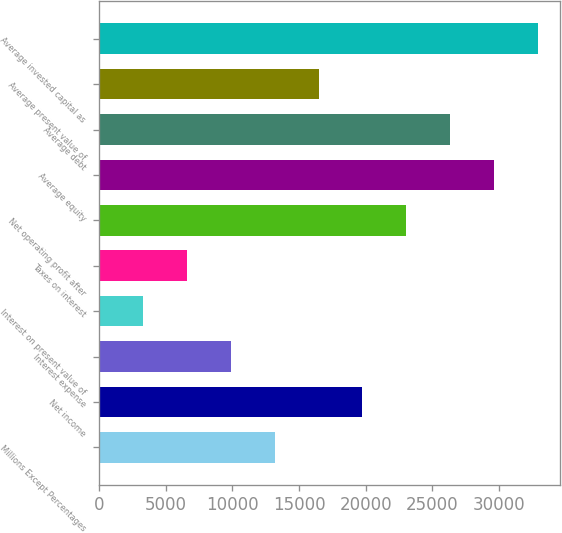Convert chart to OTSL. <chart><loc_0><loc_0><loc_500><loc_500><bar_chart><fcel>Millions Except Percentages<fcel>Net income<fcel>Interest expense<fcel>Interest on present value of<fcel>Taxes on interest<fcel>Net operating profit after<fcel>Average equity<fcel>Average debt<fcel>Average present value of<fcel>Average invested capital as<nl><fcel>13174.8<fcel>19754.9<fcel>9884.79<fcel>3304.73<fcel>6594.76<fcel>23044.9<fcel>29625<fcel>26334.9<fcel>16464.8<fcel>32915<nl></chart> 